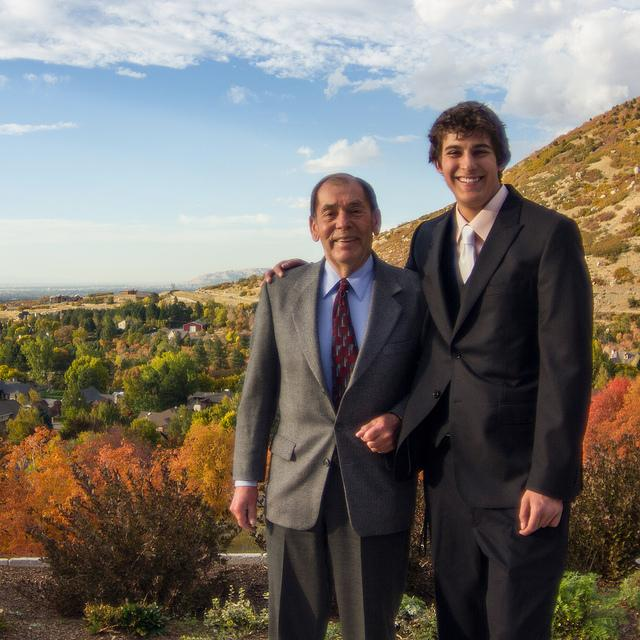What type setting do these men pose in?

Choices:
A) circus
B) suburban
C) city
D) farm farm 